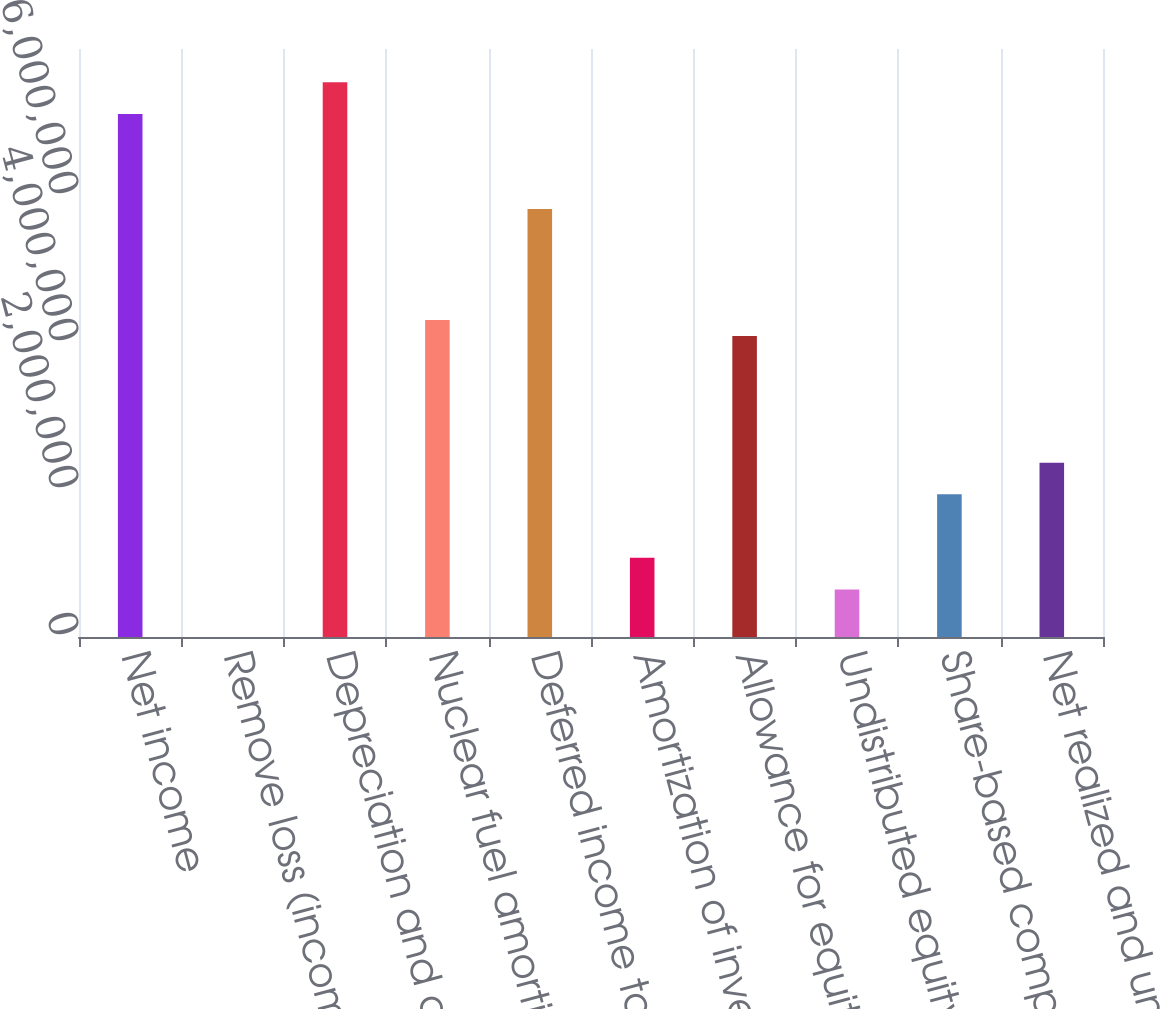Convert chart. <chart><loc_0><loc_0><loc_500><loc_500><bar_chart><fcel>Net income<fcel>Remove loss (income) from<fcel>Depreciation and amortization<fcel>Nuclear fuel amortization<fcel>Deferred income taxes<fcel>Amortization of investment tax<fcel>Allowance for equity funds<fcel>Undistributed equity in<fcel>Share-based compensation<fcel>Net realized and unrealized<nl><fcel>7.11546e+06<fcel>166<fcel>7.54669e+06<fcel>4.31247e+06<fcel>5.82177e+06<fcel>1.07824e+06<fcel>4.09685e+06<fcel>647011<fcel>1.9407e+06<fcel>2.37193e+06<nl></chart> 